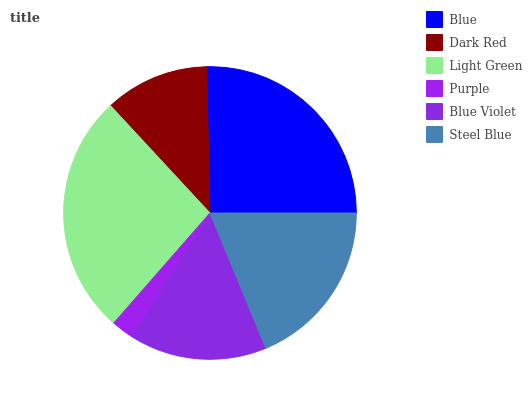Is Purple the minimum?
Answer yes or no. Yes. Is Light Green the maximum?
Answer yes or no. Yes. Is Dark Red the minimum?
Answer yes or no. No. Is Dark Red the maximum?
Answer yes or no. No. Is Blue greater than Dark Red?
Answer yes or no. Yes. Is Dark Red less than Blue?
Answer yes or no. Yes. Is Dark Red greater than Blue?
Answer yes or no. No. Is Blue less than Dark Red?
Answer yes or no. No. Is Steel Blue the high median?
Answer yes or no. Yes. Is Blue Violet the low median?
Answer yes or no. Yes. Is Blue Violet the high median?
Answer yes or no. No. Is Light Green the low median?
Answer yes or no. No. 